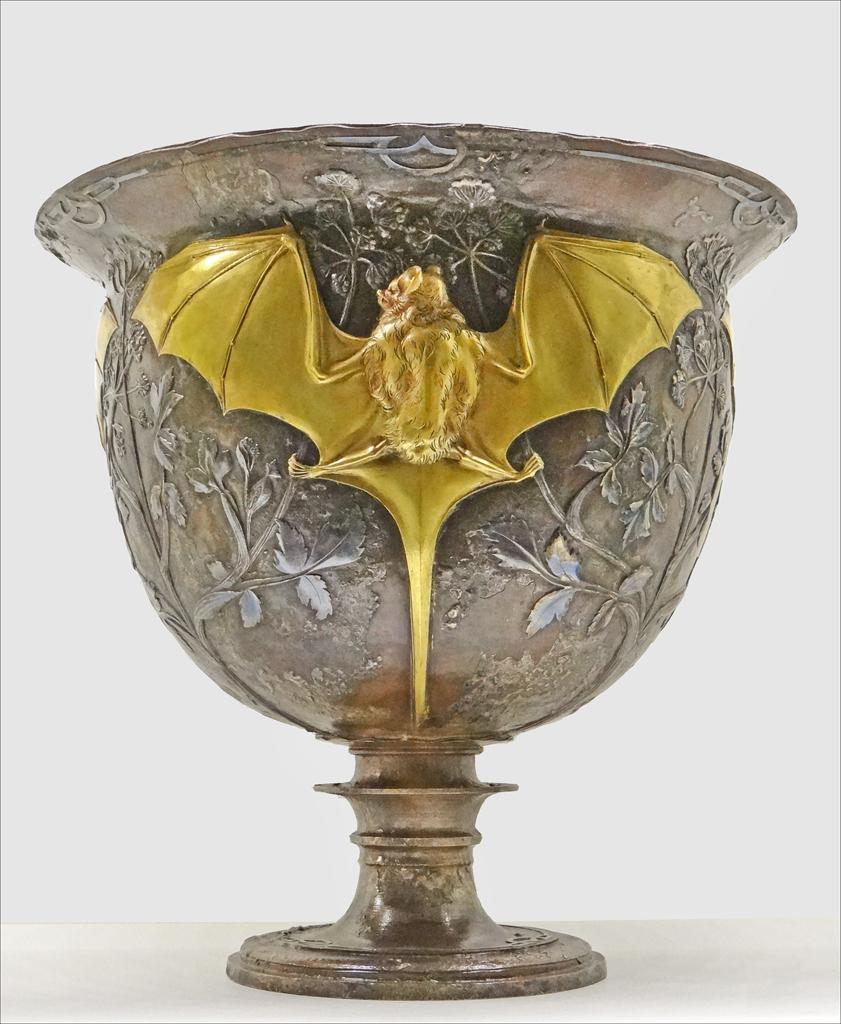What object can be seen in the picture? There is a vase in the picture. What is depicted on the vase? There is a brass bat stamping on the vase. How many records can be seen stacked next to the vase in the image? There are no records present in the image; it only features a vase with a brass bat stamping on it. 